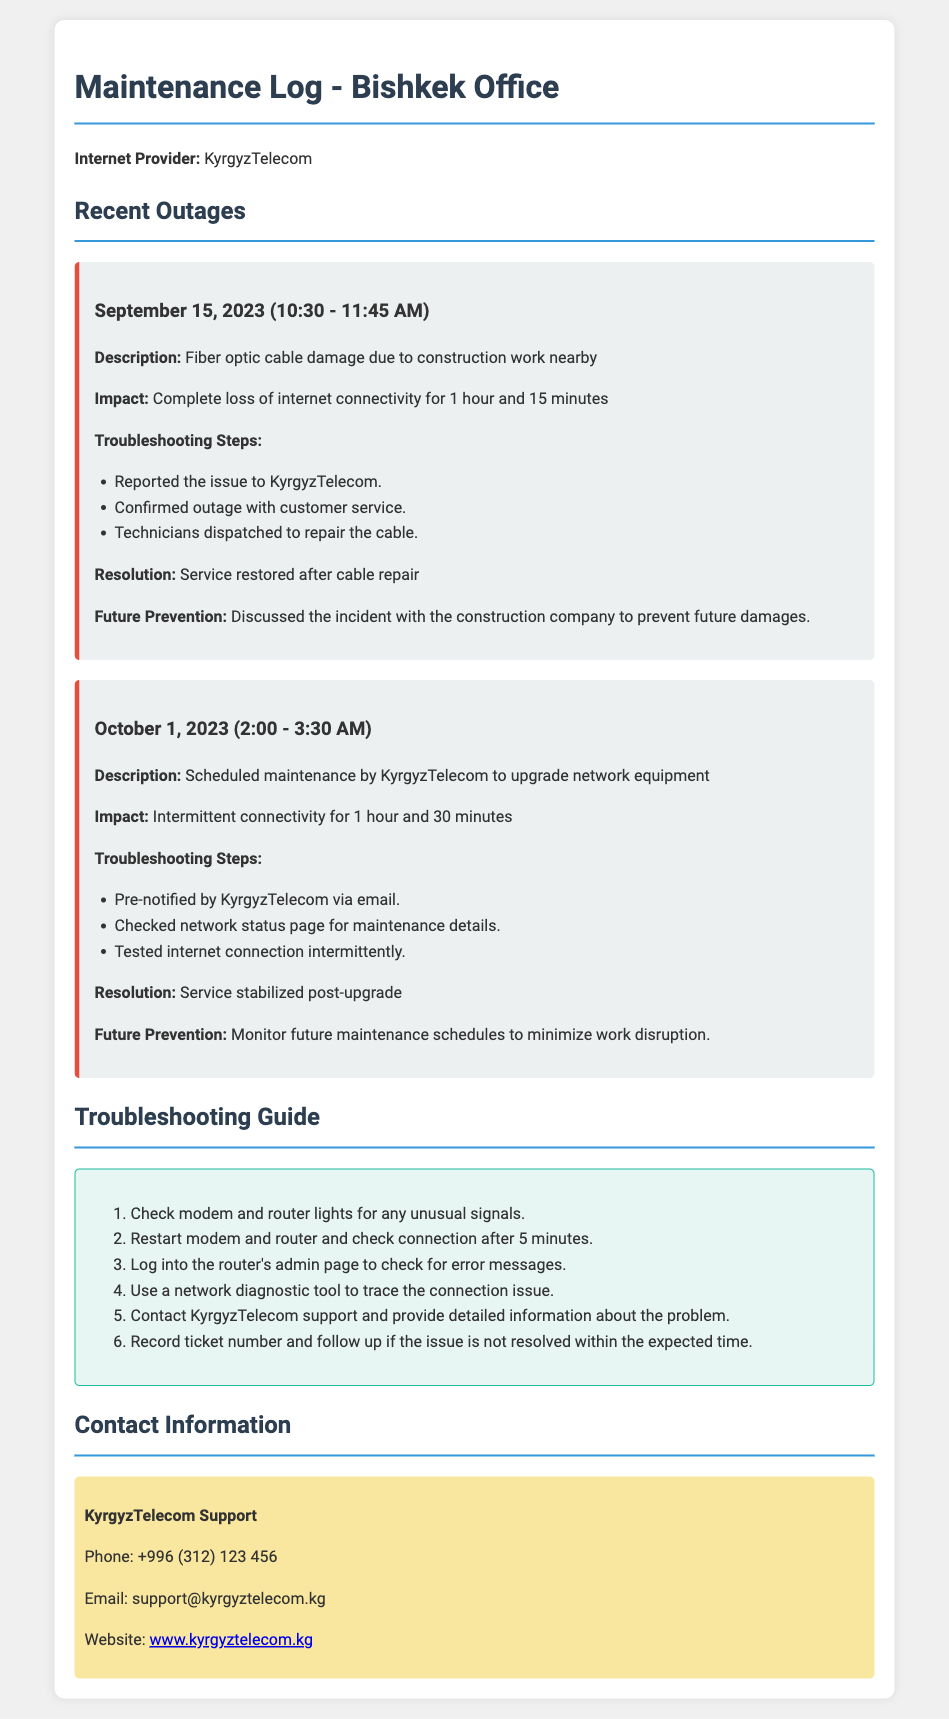What is the internet provider? The document states that the internet provider is KyrgyzTelecom.
Answer: KyrgyzTelecom What was the first outage date? The first outage recorded in the document occurred on September 15, 2023.
Answer: September 15, 2023 What was the impact of the outage on September 15? The document states that the impact was a complete loss of internet connectivity for 1 hour and 15 minutes.
Answer: Complete loss of internet connectivity for 1 hour and 15 minutes What steps were taken to troubleshoot the outage on October 1? The troubleshooting steps listed include pre-notification by KyrgyzTelecom, checking the network status page, and testing the internet connection intermittently.
Answer: Pre-notified by KyrgyzTelecom, checked network status page, tested internet connection intermittently What was the resolution for the outage on September 15? The document indicates that the service was restored after the cable repair.
Answer: Service restored after cable repair How many minutes was the outage on October 1? The outage lasted for 90 minutes, as stated in the document.
Answer: 90 minutes What future prevention measure was discussed after the September outage? The document specifies that the future prevention measure involved discussing the incident with the construction company to prevent future damages.
Answer: Discussed the incident with the construction company What is KyrgyzTelecom's support email? The support email for KyrgyzTelecom listed in the document is support@kyrgyztelecom.kg.
Answer: support@kyrgyztelecom.kg 